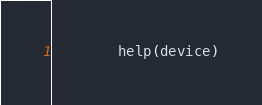<code> <loc_0><loc_0><loc_500><loc_500><_Python_>        help(device)
</code> 